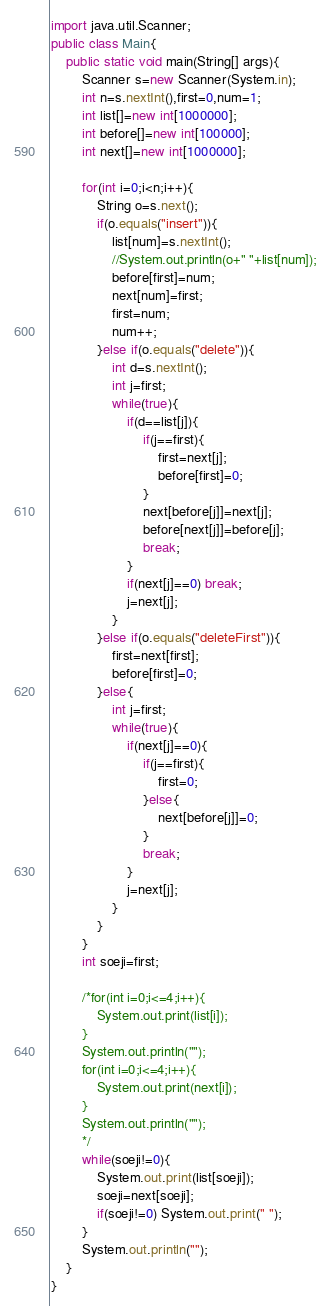<code> <loc_0><loc_0><loc_500><loc_500><_Java_>import java.util.Scanner;
public class Main{
    public static void main(String[] args){
        Scanner s=new Scanner(System.in);
        int n=s.nextInt(),first=0,num=1;
        int list[]=new int[1000000];
        int before[]=new int[100000];
        int next[]=new int[1000000];

        for(int i=0;i<n;i++){
            String o=s.next();
            if(o.equals("insert")){
                list[num]=s.nextInt();
                //System.out.println(o+" "+list[num]);
                before[first]=num;
                next[num]=first;
                first=num;
                num++;
            }else if(o.equals("delete")){
                int d=s.nextInt();
                int j=first;
                while(true){
                    if(d==list[j]){
                        if(j==first){
                            first=next[j];
                            before[first]=0;
                        }
                        next[before[j]]=next[j];
                        before[next[j]]=before[j];
                        break;
                    }
                    if(next[j]==0) break;
                    j=next[j];
                }
            }else if(o.equals("deleteFirst")){
                first=next[first];
                before[first]=0;
            }else{
                int j=first;
                while(true){
                    if(next[j]==0){
                        if(j==first){
                            first=0;
                        }else{
                            next[before[j]]=0;
                        }
                        break;
                    }
                    j=next[j];
                }
            }
        }
        int soeji=first;

        /*for(int i=0;i<=4;i++){
            System.out.print(list[i]);
        }
        System.out.println("");
        for(int i=0;i<=4;i++){
            System.out.print(next[i]);
        }
        System.out.println("");
        */
        while(soeji!=0){
            System.out.print(list[soeji]);
            soeji=next[soeji];
            if(soeji!=0) System.out.print(" ");
        }
        System.out.println("");
    }
}
</code> 